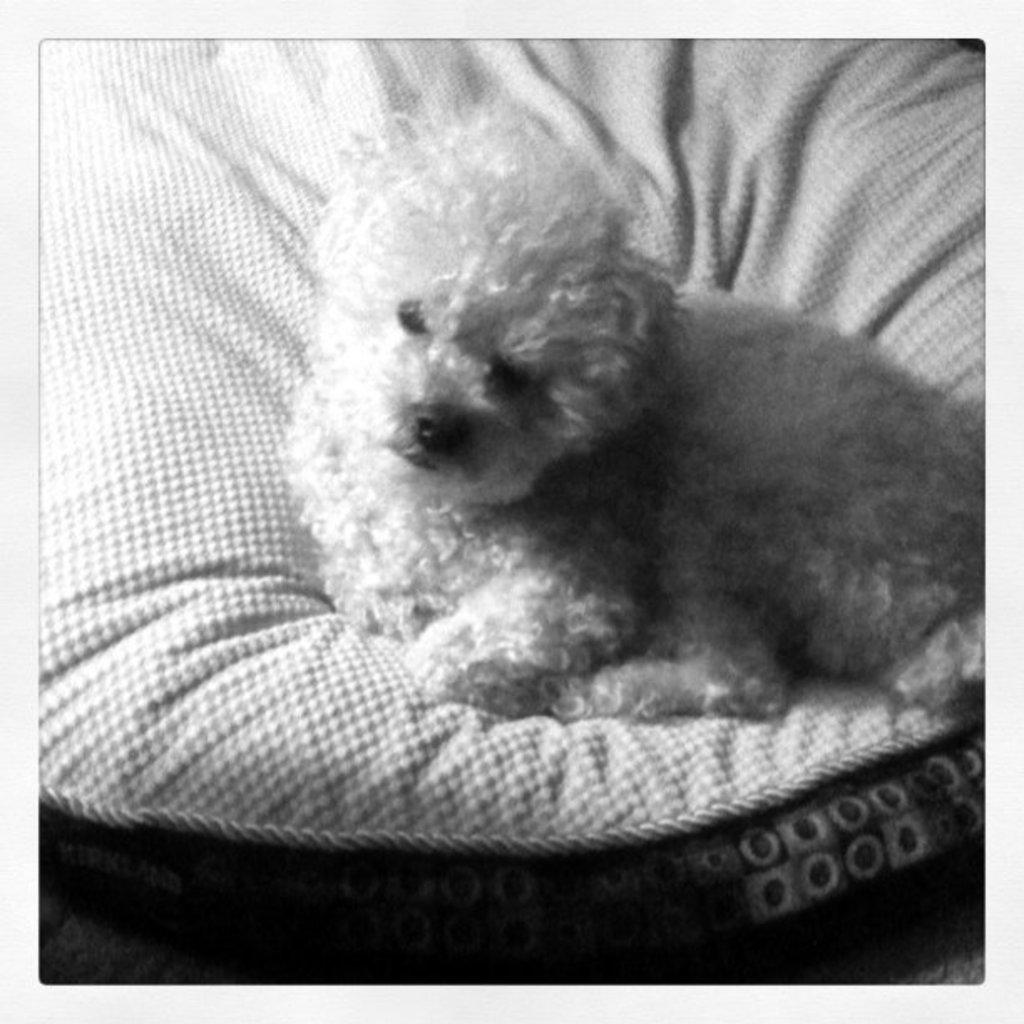What is the color scheme of the image? The image is black and white. What type of dog is in the image? There is a miniature poodle in the image. Where is the poodle sitting in the image? The poodle is sitting on a couch. What part of the room can be seen at the bottom of the image? The floor is visible at the bottom of the image. What type of joke is the poodle telling in the image? There is no indication in the image that the poodle is telling a joke, as it is simply sitting on a couch. Can you tell me how much honey the poodle is holding in the image? There is no honey present in the image, and therefore no amount can be determined. 